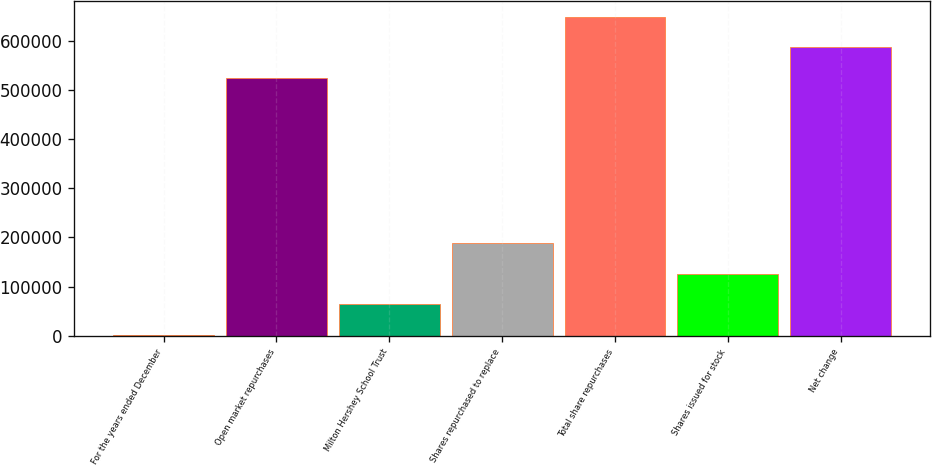<chart> <loc_0><loc_0><loc_500><loc_500><bar_chart><fcel>For the years ended December<fcel>Open market repurchases<fcel>Milton Hershey School Trust<fcel>Shares repurchased to replace<fcel>Total share repurchases<fcel>Shares issued for stock<fcel>Net change<nl><fcel>2006<fcel>524387<fcel>63970.2<fcel>187899<fcel>648315<fcel>125934<fcel>586351<nl></chart> 